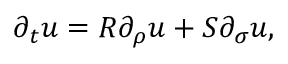<formula> <loc_0><loc_0><loc_500><loc_500>\partial _ { t } u = R \partial _ { \rho } u + S \partial _ { \sigma } u ,</formula> 